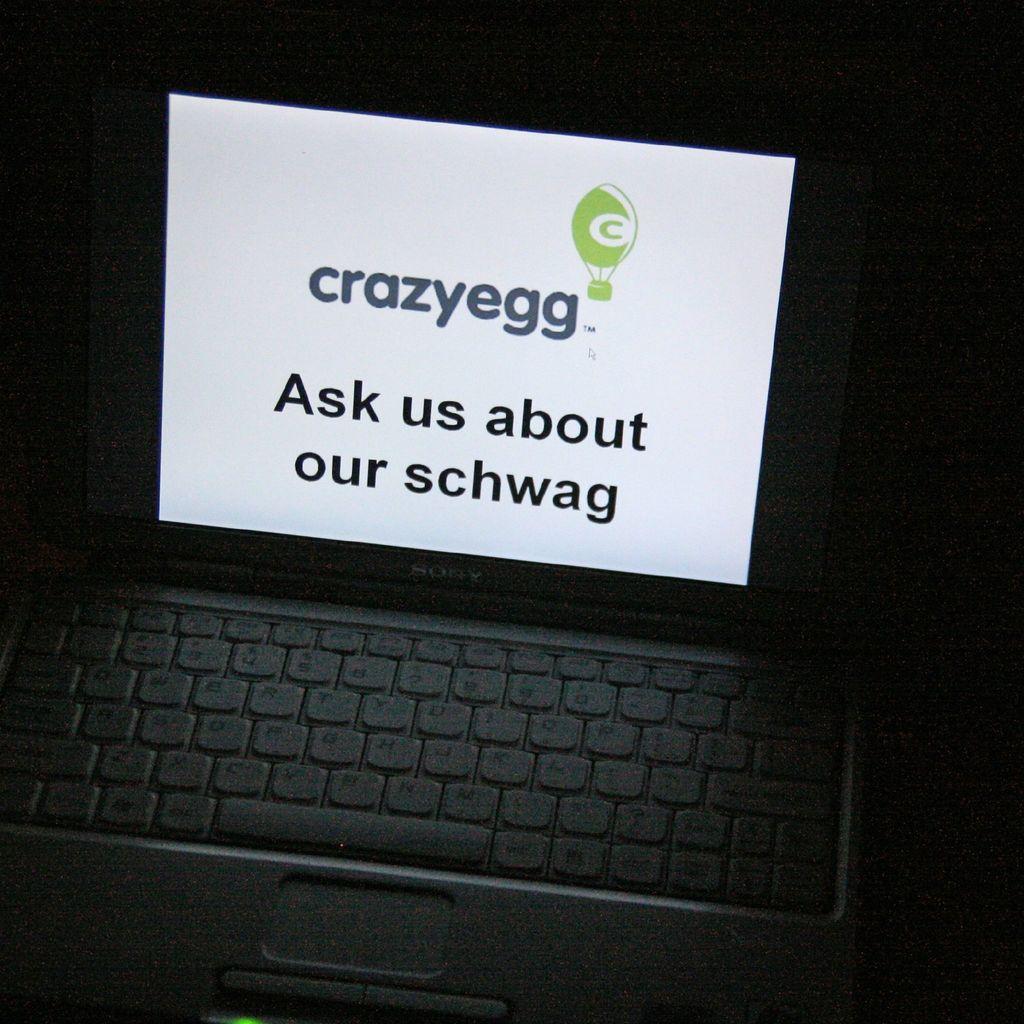What is the name of the site?
Ensure brevity in your answer.  Crazyegg. 